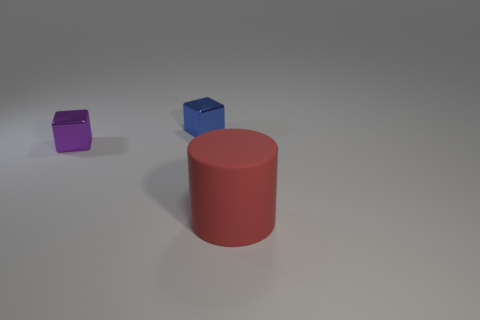How would you describe the lighting and shadows in the scene? The lighting in the scene is soft and diffused, casting gentle shadows to the right of the objects. The use of shadows contributes to the depth and dimensionality of the image, creating a sense of space. 